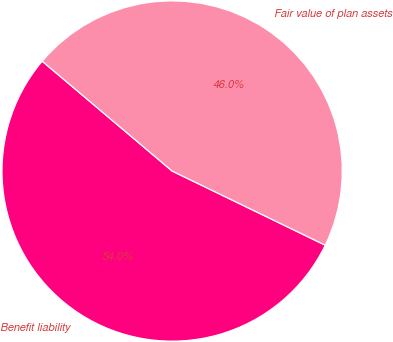<chart> <loc_0><loc_0><loc_500><loc_500><pie_chart><fcel>Benefit liability<fcel>Fair value of plan assets<nl><fcel>53.99%<fcel>46.01%<nl></chart> 